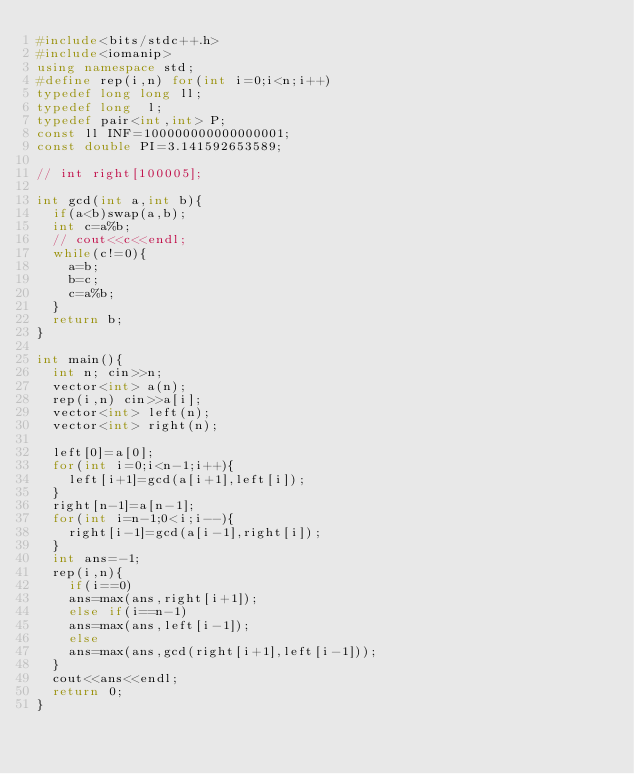Convert code to text. <code><loc_0><loc_0><loc_500><loc_500><_C++_>#include<bits/stdc++.h>
#include<iomanip>
using namespace std;
#define rep(i,n) for(int i=0;i<n;i++)
typedef long long ll;
typedef long  l;
typedef pair<int,int> P;
const ll INF=100000000000000001;
const double PI=3.141592653589;

// int right[100005];

int gcd(int a,int b){
  if(a<b)swap(a,b);
  int c=a%b;
  // cout<<c<<endl;
  while(c!=0){
    a=b;
    b=c;
    c=a%b;
  }
  return b;
}

int main(){
  int n; cin>>n;
  vector<int> a(n);
  rep(i,n) cin>>a[i];
  vector<int> left(n);
  vector<int> right(n);

  left[0]=a[0];
  for(int i=0;i<n-1;i++){
    left[i+1]=gcd(a[i+1],left[i]);
  }
  right[n-1]=a[n-1];
  for(int i=n-1;0<i;i--){
    right[i-1]=gcd(a[i-1],right[i]);
  }
  int ans=-1;
  rep(i,n){
    if(i==0)
    ans=max(ans,right[i+1]);
    else if(i==n-1)
    ans=max(ans,left[i-1]);
    else
    ans=max(ans,gcd(right[i+1],left[i-1]));
  }
  cout<<ans<<endl;
  return 0;
}
</code> 